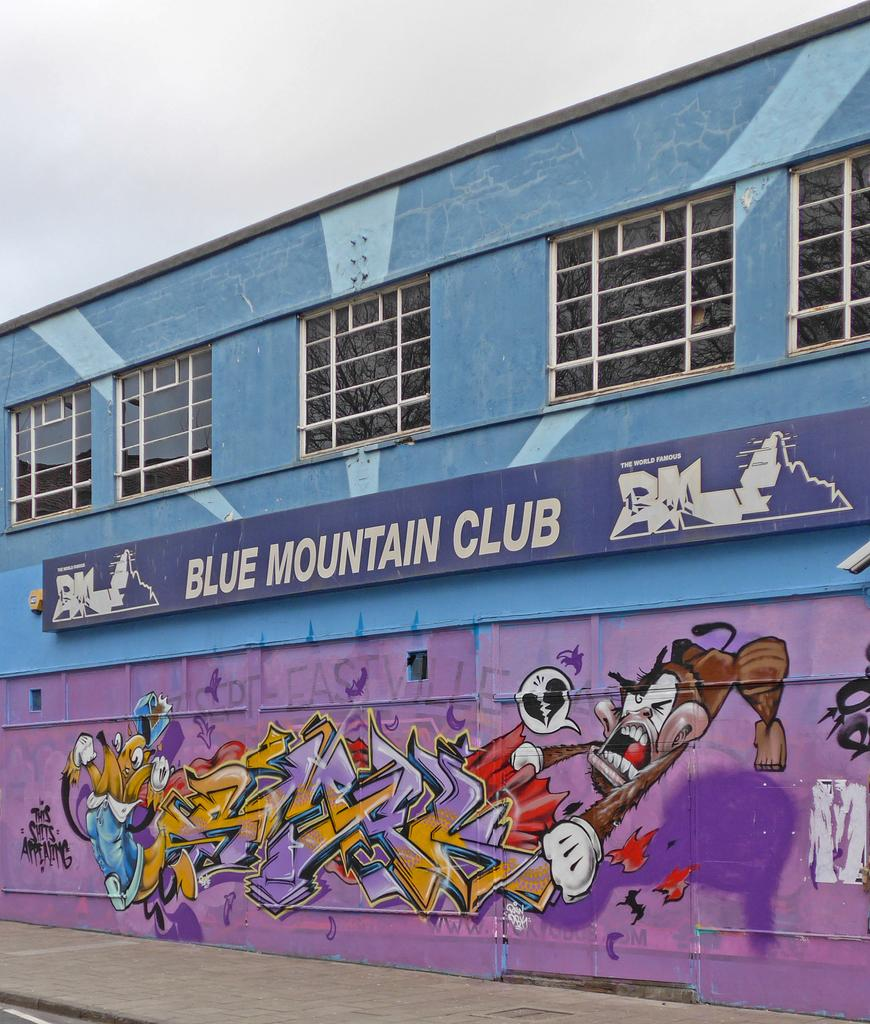Provide a one-sentence caption for the provided image. the side of a building with graffiti and the name blue mountain club in white. 